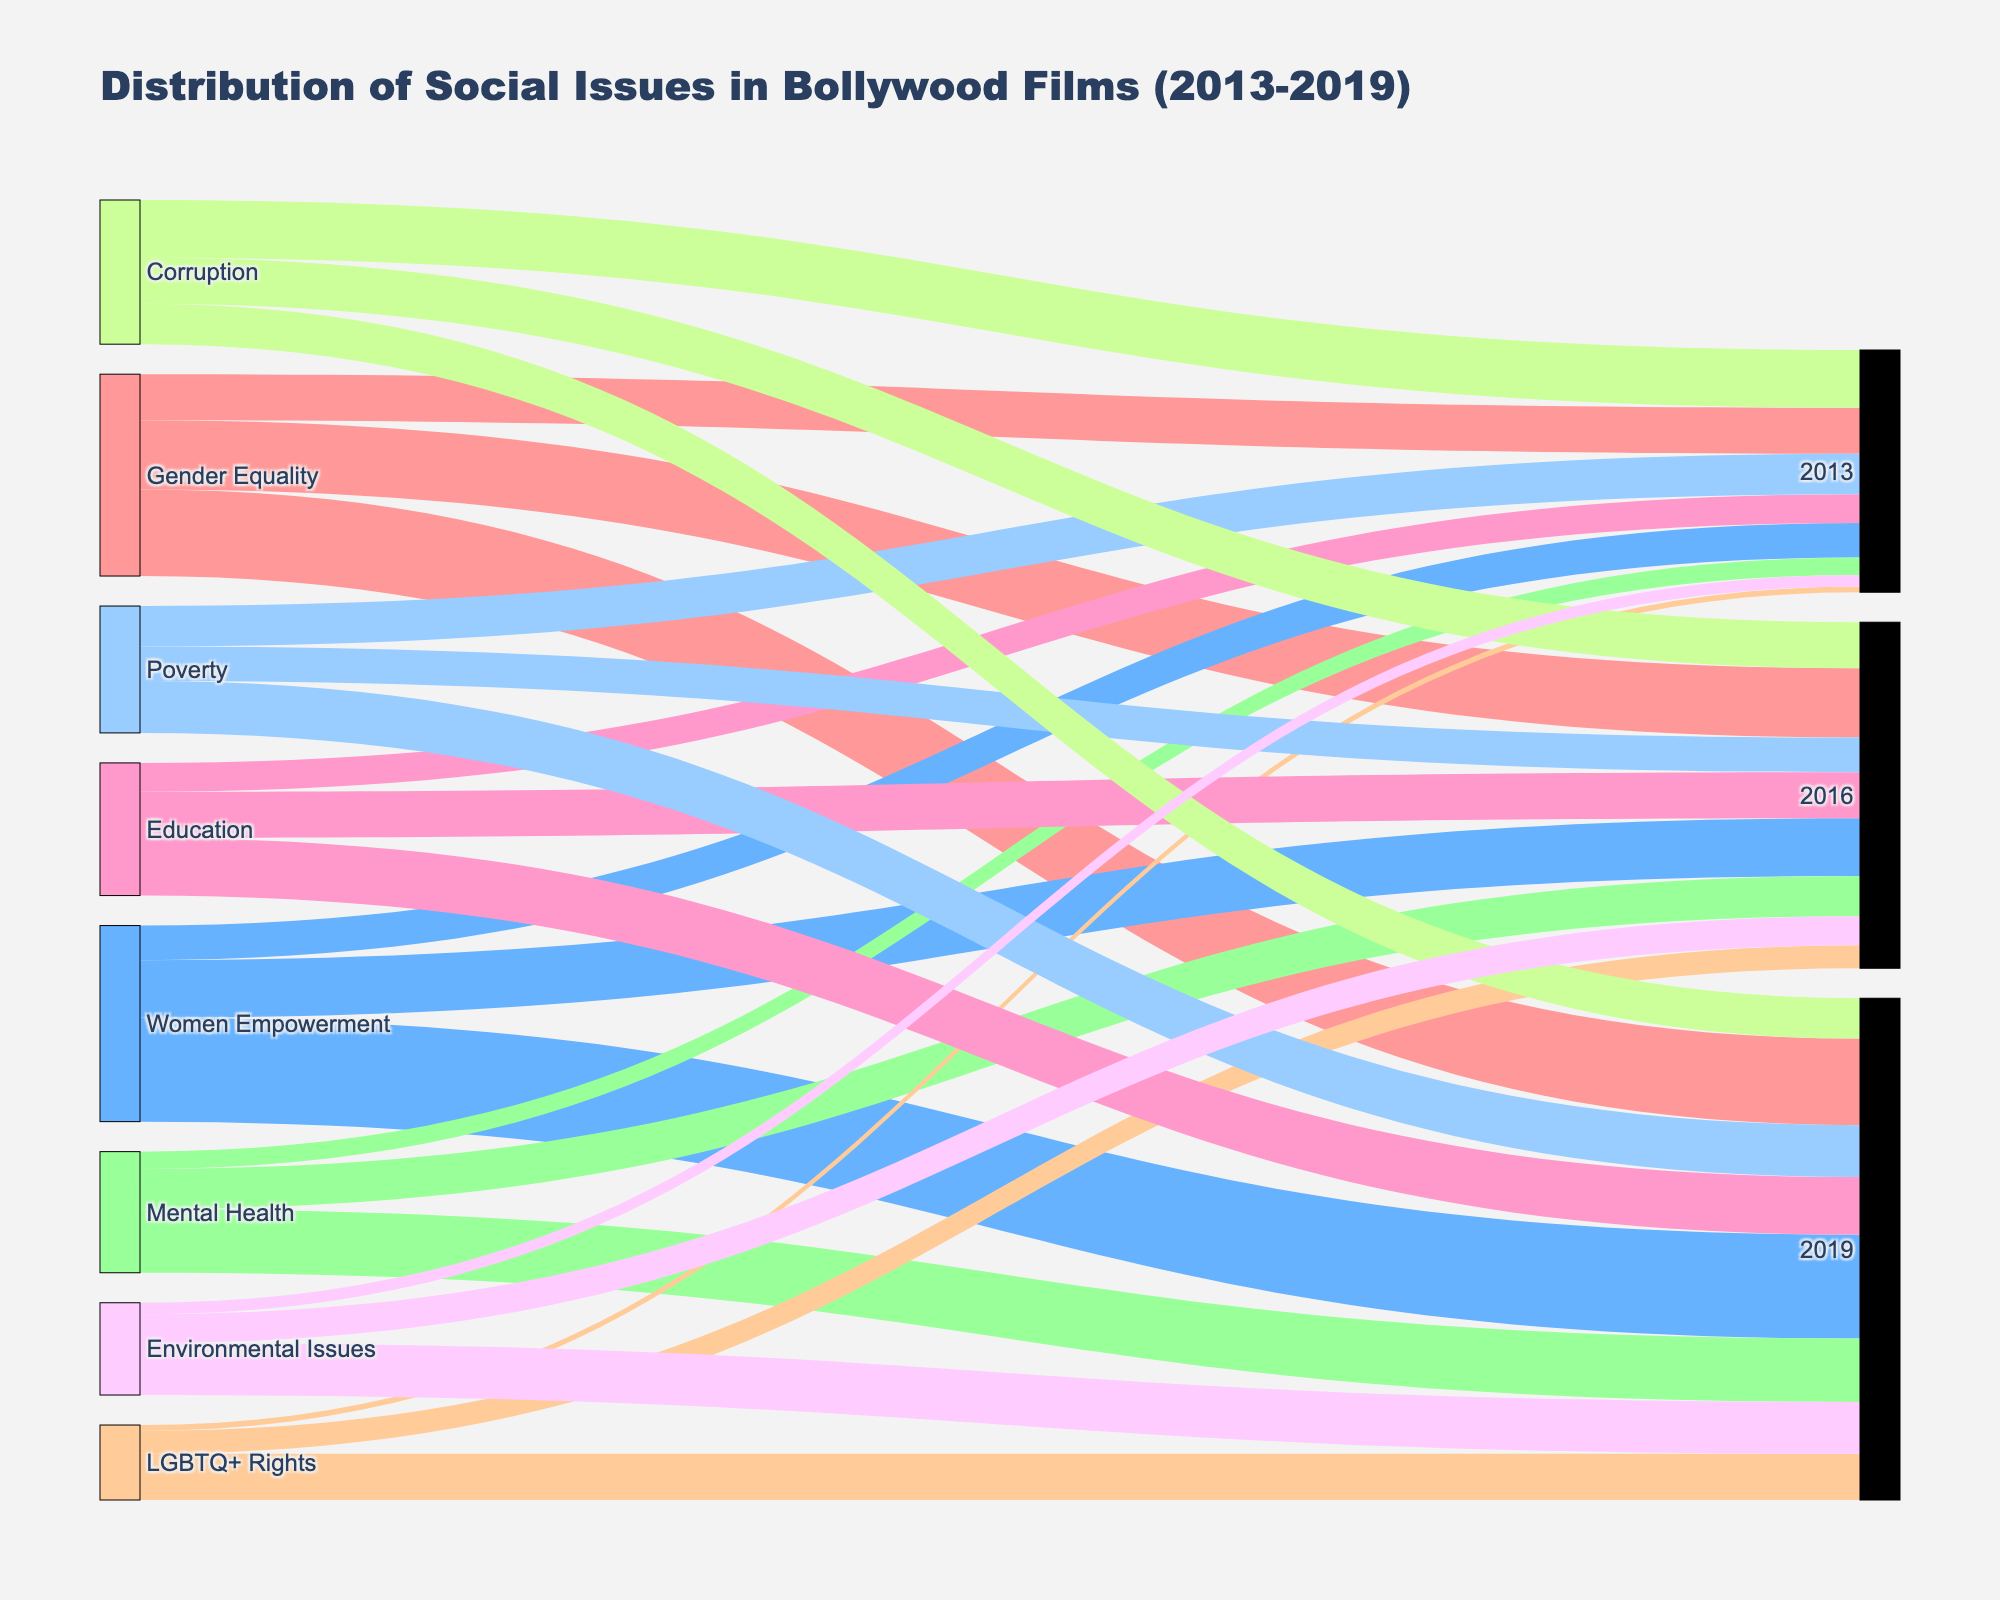What social issue had the highest number of films in 2019? Scan through the nodes connected to 2019 and check the values; Women Empowerment has the highest value of 18.
Answer: Women Empowerment What is the total number of films addressing Gender Equality from 2013 to 2019? Sum the film counts for Gender Equality in 2013, 2016, and 2019 (8 + 12 + 15).
Answer: 35 Which social issue had fewer films in 2013 compared to 2016, but more in 2019? Compare film counts in 2013, 2016, and 2019; Mental Health: 3 in 2013, 7 in 2016, 11 in 2019.
Answer: Mental Health How many films addressed Environmental Issues in 2013? Locate the node representing Environmental Issues in 2013; the value is 2.
Answer: 2 Which year saw the highest number of Bollywood films addressing LGBTQ+ Rights? Check the film counts for LGBTQ+ Rights in each year (2013, 2016, 2019); maximum is in 2019 with 8 films.
Answer: 2019 Between 2013 and 2019, which social issue showed a consistent increase in the number of films? Compare film counts over the years; Women Empowerment consistently increases (6, 10, 18).
Answer: Women Empowerment What is the combined total of films addressing Poverty in 2013 and 2019? Add film counts for Poverty in 2013 and 2019 (7 + 9).
Answer: 16 Which social issue saw a decrease in the number of films from 2013 to 2019? Compare film counts over the years for all issues; Corruption decreases (10 in 2013, 8 in 2016, 7 in 2019).
Answer: Corruption How many social issues had film counts greater than 10 in 2019? Look at the values connected to 2019 and count those greater than 10; Gender Equality, Women Empowerment, and Mental Health.
Answer: 3 What is the trend observed for films addressing Education from 2013 to 2019? Check the film counts for Education over the years (2013: 5, 2016: 8, 2019: 10); it shows an increasing trend.
Answer: Increasing 